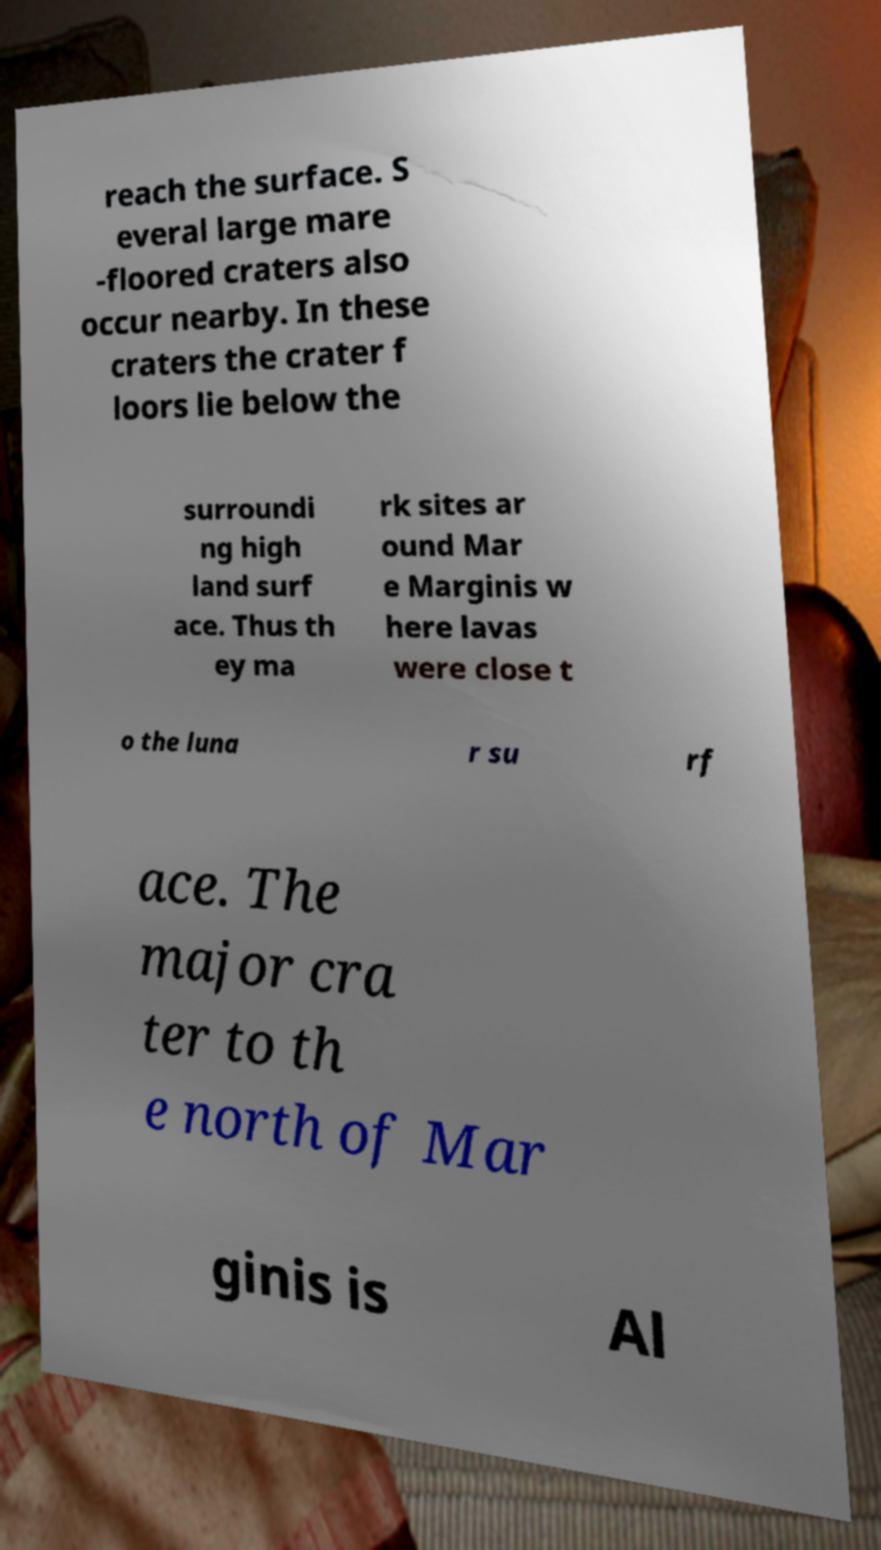Can you accurately transcribe the text from the provided image for me? reach the surface. S everal large mare -floored craters also occur nearby. In these craters the crater f loors lie below the surroundi ng high land surf ace. Thus th ey ma rk sites ar ound Mar e Marginis w here lavas were close t o the luna r su rf ace. The major cra ter to th e north of Mar ginis is Al 